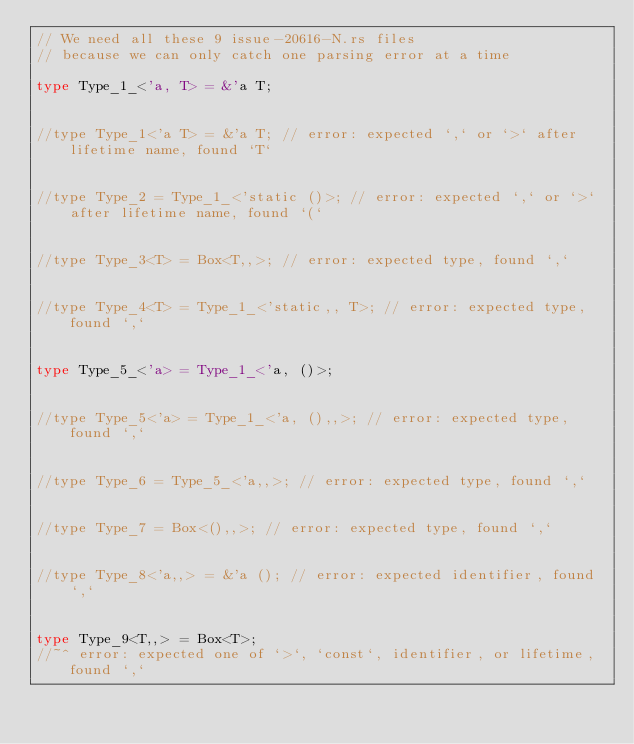<code> <loc_0><loc_0><loc_500><loc_500><_Rust_>// We need all these 9 issue-20616-N.rs files
// because we can only catch one parsing error at a time

type Type_1_<'a, T> = &'a T;


//type Type_1<'a T> = &'a T; // error: expected `,` or `>` after lifetime name, found `T`


//type Type_2 = Type_1_<'static ()>; // error: expected `,` or `>` after lifetime name, found `(`


//type Type_3<T> = Box<T,,>; // error: expected type, found `,`


//type Type_4<T> = Type_1_<'static,, T>; // error: expected type, found `,`


type Type_5_<'a> = Type_1_<'a, ()>;


//type Type_5<'a> = Type_1_<'a, (),,>; // error: expected type, found `,`


//type Type_6 = Type_5_<'a,,>; // error: expected type, found `,`


//type Type_7 = Box<(),,>; // error: expected type, found `,`


//type Type_8<'a,,> = &'a (); // error: expected identifier, found `,`


type Type_9<T,,> = Box<T>;
//~^ error: expected one of `>`, `const`, identifier, or lifetime, found `,`
</code> 